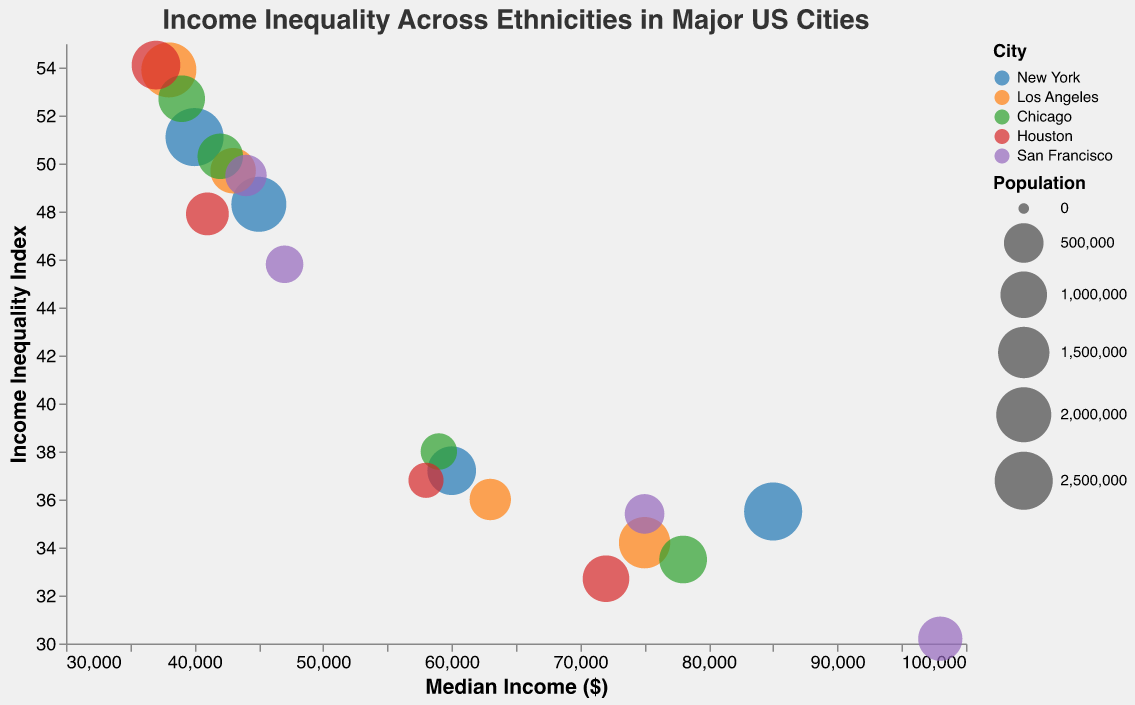How many data points represent Los Angeles? Identify the color corresponding to Los Angeles in the legend and count the number of circles with this color on the chart. Los Angeles is represented by the orange color, and there are 4 data points.
Answer: 4 Which ethnicity in Houston has the highest median income? Look for the circles labeled "Houston" and compare the median incomes among different ethnicities. White has a median income of $72,000, Black $41,000, Hispanic $37,000, and Asian $58,000. White has the highest median income.
Answer: White What is the Income Inequality Index for Hispanics in Chicago? Find the circle representing Hispanics in Chicago and read the Income Inequality Index value from the tooltip. The value is 52.7.
Answer: 52.7 Which city has the lowest Income Inequality Index among White populations? Compare the Income Inequality Index values for White populations across all cities. San Francisco has the lowest value of 30.2.
Answer: San Francisco What's the average Median Income for Asians across all cities? Add the median incomes for Asians in each city and divide by the number of cities: (60000 + 63000 + 59000 + 58000 + 75000) / 5 = 63,800.
Answer: 63,800 Compare the Income Inequality Index of Hispanics in Los Angeles to those in Houston. Which one is higher? Find the circles for Hispanics in Los Angeles and Houston and compare their Income Inequality Index values. Los Angeles has 53.9, and Houston has 54.1. Houston is higher.
Answer: Houston How does the population size of Blacks in New York compare to that of Hispanics in San Francisco? Compare the sizes of the circles representing Blacks in New York (2000000) and Hispanics in San Francisco (600000). The population of Blacks in New York is larger.
Answer: New York Which ethnicity in San Francisco has the highest Income Inequality Index? Look for circles labeled "San Francisco" and compare their Income Inequality Index values among different ethnicities. Hispanic has the highest value of 49.5.
Answer: Hispanic What is the difference in the Median Income between Whites and Blacks in New York? Subtract the median income of Blacks ($45,000) from that of Whites ($85,000) in New York. The difference is $40,000.
Answer: 40,000 In which city do Asians have the highest Median Income? Compare the Median Income values for Asians across all cities. San Francisco has the highest value of $75,000.
Answer: San Francisco 